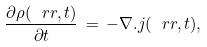<formula> <loc_0><loc_0><loc_500><loc_500>\frac { \partial \rho ( \ r r , t ) } { \partial t } \, = \, - \nabla . j ( \ r r , t ) ,</formula> 